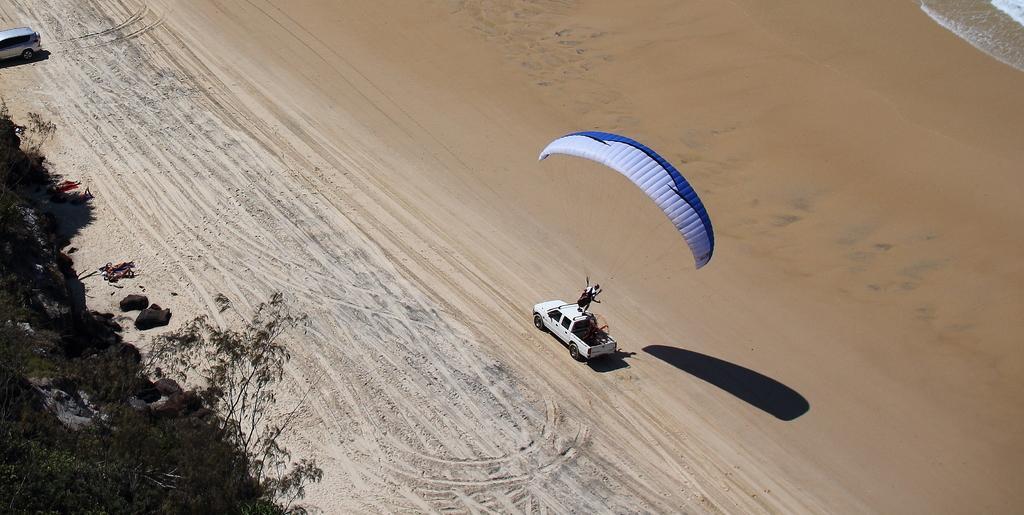In one or two sentences, can you explain what this image depicts? In this picture we can see the top view of the seaside. In front there is a white color gypsy on which a man is standing with blue color parachute. Behind we can see water waves and sea sand. On the left side of the image we can see some stones and trees. 